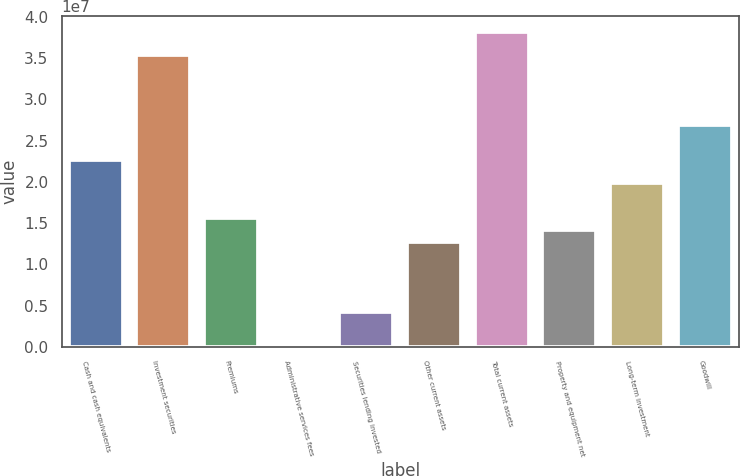Convert chart. <chart><loc_0><loc_0><loc_500><loc_500><bar_chart><fcel>Cash and cash equivalents<fcel>Investment securities<fcel>Premiums<fcel>Administrative services fees<fcel>Securities lending invested<fcel>Other current assets<fcel>Total current assets<fcel>Property and equipment net<fcel>Long-term investment<fcel>Goodwill<nl><fcel>2.26385e+07<fcel>3.5366e+07<fcel>1.55677e+07<fcel>11820<fcel>4.25432e+06<fcel>1.27393e+07<fcel>3.81943e+07<fcel>1.41535e+07<fcel>1.98102e+07<fcel>2.6881e+07<nl></chart> 